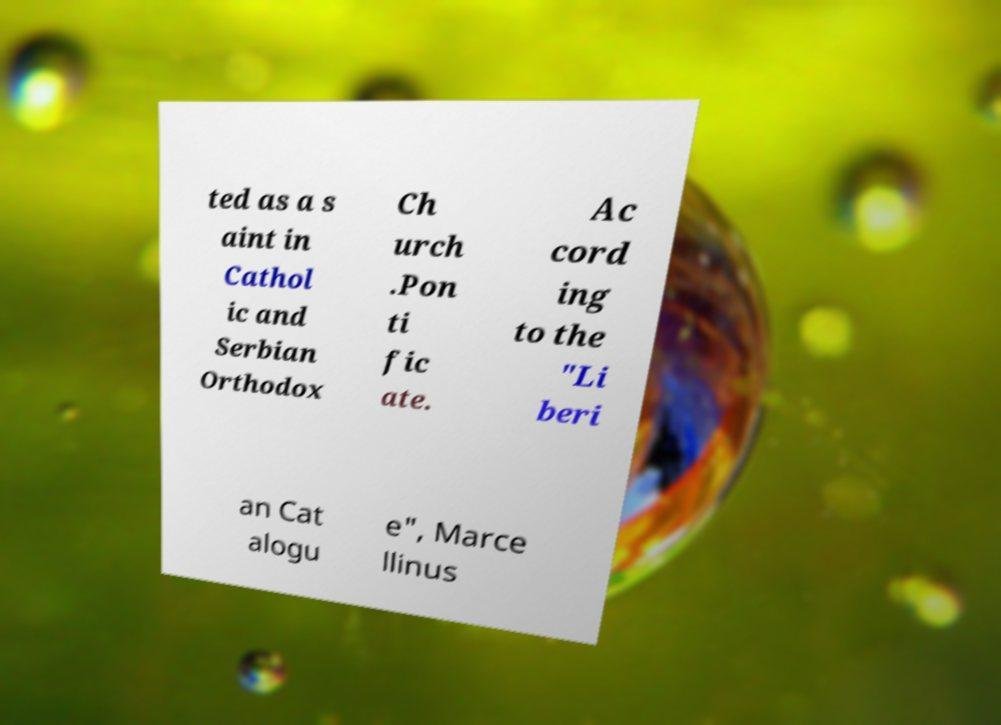Can you accurately transcribe the text from the provided image for me? ted as a s aint in Cathol ic and Serbian Orthodox Ch urch .Pon ti fic ate. Ac cord ing to the "Li beri an Cat alogu e", Marce llinus 